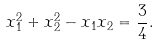Convert formula to latex. <formula><loc_0><loc_0><loc_500><loc_500>x _ { 1 } ^ { 2 } + x _ { 2 } ^ { 2 } - x _ { 1 } x _ { 2 } = { \frac { 3 } { 4 } } .</formula> 